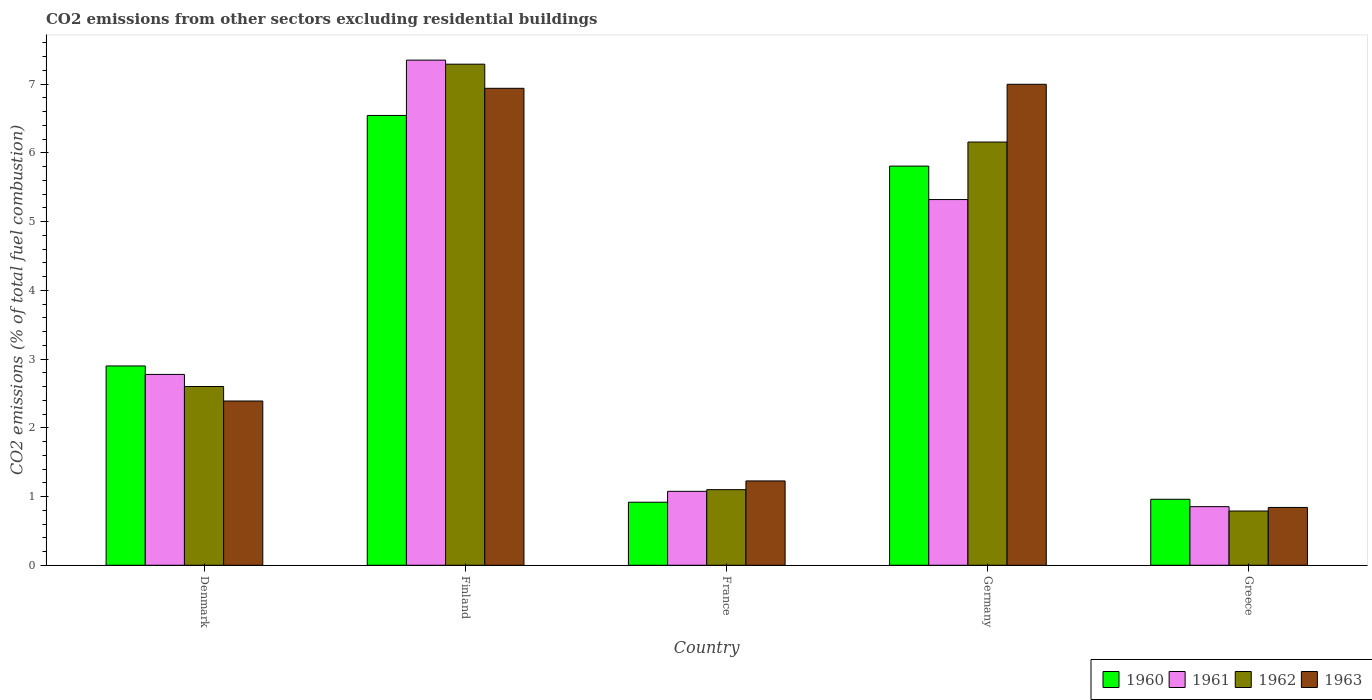How many groups of bars are there?
Your answer should be compact. 5. How many bars are there on the 2nd tick from the right?
Offer a terse response. 4. What is the label of the 4th group of bars from the left?
Your answer should be very brief. Germany. In how many cases, is the number of bars for a given country not equal to the number of legend labels?
Your answer should be very brief. 0. What is the total CO2 emitted in 1963 in Greece?
Ensure brevity in your answer.  0.84. Across all countries, what is the maximum total CO2 emitted in 1961?
Make the answer very short. 7.35. Across all countries, what is the minimum total CO2 emitted in 1961?
Offer a very short reply. 0.85. In which country was the total CO2 emitted in 1963 maximum?
Ensure brevity in your answer.  Germany. In which country was the total CO2 emitted in 1963 minimum?
Ensure brevity in your answer.  Greece. What is the total total CO2 emitted in 1963 in the graph?
Give a very brief answer. 18.4. What is the difference between the total CO2 emitted in 1962 in Finland and that in Germany?
Give a very brief answer. 1.13. What is the difference between the total CO2 emitted in 1963 in Greece and the total CO2 emitted in 1962 in Denmark?
Offer a very short reply. -1.76. What is the average total CO2 emitted in 1962 per country?
Your response must be concise. 3.59. What is the difference between the total CO2 emitted of/in 1961 and total CO2 emitted of/in 1962 in France?
Keep it short and to the point. -0.02. In how many countries, is the total CO2 emitted in 1960 greater than 5.2?
Make the answer very short. 2. What is the ratio of the total CO2 emitted in 1960 in Germany to that in Greece?
Ensure brevity in your answer.  6.05. What is the difference between the highest and the second highest total CO2 emitted in 1961?
Provide a succinct answer. -2.54. What is the difference between the highest and the lowest total CO2 emitted in 1960?
Offer a terse response. 5.63. Is the sum of the total CO2 emitted in 1963 in Finland and France greater than the maximum total CO2 emitted in 1960 across all countries?
Give a very brief answer. Yes. Is it the case that in every country, the sum of the total CO2 emitted in 1961 and total CO2 emitted in 1962 is greater than the sum of total CO2 emitted in 1963 and total CO2 emitted in 1960?
Your response must be concise. No. Is it the case that in every country, the sum of the total CO2 emitted in 1962 and total CO2 emitted in 1963 is greater than the total CO2 emitted in 1960?
Ensure brevity in your answer.  Yes. Are all the bars in the graph horizontal?
Offer a terse response. No. How many countries are there in the graph?
Offer a very short reply. 5. Are the values on the major ticks of Y-axis written in scientific E-notation?
Ensure brevity in your answer.  No. Does the graph contain any zero values?
Keep it short and to the point. No. Does the graph contain grids?
Keep it short and to the point. No. What is the title of the graph?
Your response must be concise. CO2 emissions from other sectors excluding residential buildings. What is the label or title of the X-axis?
Keep it short and to the point. Country. What is the label or title of the Y-axis?
Make the answer very short. CO2 emissions (% of total fuel combustion). What is the CO2 emissions (% of total fuel combustion) of 1960 in Denmark?
Offer a terse response. 2.9. What is the CO2 emissions (% of total fuel combustion) in 1961 in Denmark?
Offer a terse response. 2.78. What is the CO2 emissions (% of total fuel combustion) of 1962 in Denmark?
Offer a very short reply. 2.6. What is the CO2 emissions (% of total fuel combustion) of 1963 in Denmark?
Offer a terse response. 2.39. What is the CO2 emissions (% of total fuel combustion) of 1960 in Finland?
Provide a short and direct response. 6.54. What is the CO2 emissions (% of total fuel combustion) of 1961 in Finland?
Keep it short and to the point. 7.35. What is the CO2 emissions (% of total fuel combustion) of 1962 in Finland?
Make the answer very short. 7.29. What is the CO2 emissions (% of total fuel combustion) in 1963 in Finland?
Your answer should be compact. 6.94. What is the CO2 emissions (% of total fuel combustion) in 1960 in France?
Your answer should be compact. 0.92. What is the CO2 emissions (% of total fuel combustion) in 1961 in France?
Make the answer very short. 1.08. What is the CO2 emissions (% of total fuel combustion) in 1962 in France?
Your answer should be very brief. 1.1. What is the CO2 emissions (% of total fuel combustion) of 1963 in France?
Ensure brevity in your answer.  1.23. What is the CO2 emissions (% of total fuel combustion) in 1960 in Germany?
Provide a succinct answer. 5.81. What is the CO2 emissions (% of total fuel combustion) in 1961 in Germany?
Your response must be concise. 5.32. What is the CO2 emissions (% of total fuel combustion) of 1962 in Germany?
Make the answer very short. 6.16. What is the CO2 emissions (% of total fuel combustion) in 1963 in Germany?
Your answer should be very brief. 7. What is the CO2 emissions (% of total fuel combustion) of 1960 in Greece?
Offer a very short reply. 0.96. What is the CO2 emissions (% of total fuel combustion) of 1961 in Greece?
Keep it short and to the point. 0.85. What is the CO2 emissions (% of total fuel combustion) of 1962 in Greece?
Your answer should be very brief. 0.79. What is the CO2 emissions (% of total fuel combustion) in 1963 in Greece?
Ensure brevity in your answer.  0.84. Across all countries, what is the maximum CO2 emissions (% of total fuel combustion) in 1960?
Ensure brevity in your answer.  6.54. Across all countries, what is the maximum CO2 emissions (% of total fuel combustion) in 1961?
Offer a very short reply. 7.35. Across all countries, what is the maximum CO2 emissions (% of total fuel combustion) of 1962?
Your response must be concise. 7.29. Across all countries, what is the maximum CO2 emissions (% of total fuel combustion) in 1963?
Provide a succinct answer. 7. Across all countries, what is the minimum CO2 emissions (% of total fuel combustion) in 1960?
Make the answer very short. 0.92. Across all countries, what is the minimum CO2 emissions (% of total fuel combustion) of 1961?
Give a very brief answer. 0.85. Across all countries, what is the minimum CO2 emissions (% of total fuel combustion) in 1962?
Make the answer very short. 0.79. Across all countries, what is the minimum CO2 emissions (% of total fuel combustion) in 1963?
Offer a very short reply. 0.84. What is the total CO2 emissions (% of total fuel combustion) in 1960 in the graph?
Keep it short and to the point. 17.13. What is the total CO2 emissions (% of total fuel combustion) of 1961 in the graph?
Make the answer very short. 17.38. What is the total CO2 emissions (% of total fuel combustion) of 1962 in the graph?
Ensure brevity in your answer.  17.94. What is the total CO2 emissions (% of total fuel combustion) of 1963 in the graph?
Keep it short and to the point. 18.4. What is the difference between the CO2 emissions (% of total fuel combustion) of 1960 in Denmark and that in Finland?
Give a very brief answer. -3.64. What is the difference between the CO2 emissions (% of total fuel combustion) of 1961 in Denmark and that in Finland?
Your response must be concise. -4.57. What is the difference between the CO2 emissions (% of total fuel combustion) in 1962 in Denmark and that in Finland?
Your response must be concise. -4.69. What is the difference between the CO2 emissions (% of total fuel combustion) of 1963 in Denmark and that in Finland?
Offer a terse response. -4.55. What is the difference between the CO2 emissions (% of total fuel combustion) in 1960 in Denmark and that in France?
Ensure brevity in your answer.  1.98. What is the difference between the CO2 emissions (% of total fuel combustion) in 1961 in Denmark and that in France?
Offer a terse response. 1.7. What is the difference between the CO2 emissions (% of total fuel combustion) of 1962 in Denmark and that in France?
Provide a short and direct response. 1.5. What is the difference between the CO2 emissions (% of total fuel combustion) of 1963 in Denmark and that in France?
Your answer should be compact. 1.16. What is the difference between the CO2 emissions (% of total fuel combustion) in 1960 in Denmark and that in Germany?
Make the answer very short. -2.91. What is the difference between the CO2 emissions (% of total fuel combustion) in 1961 in Denmark and that in Germany?
Give a very brief answer. -2.54. What is the difference between the CO2 emissions (% of total fuel combustion) in 1962 in Denmark and that in Germany?
Offer a terse response. -3.56. What is the difference between the CO2 emissions (% of total fuel combustion) in 1963 in Denmark and that in Germany?
Ensure brevity in your answer.  -4.61. What is the difference between the CO2 emissions (% of total fuel combustion) in 1960 in Denmark and that in Greece?
Make the answer very short. 1.94. What is the difference between the CO2 emissions (% of total fuel combustion) of 1961 in Denmark and that in Greece?
Keep it short and to the point. 1.92. What is the difference between the CO2 emissions (% of total fuel combustion) in 1962 in Denmark and that in Greece?
Make the answer very short. 1.81. What is the difference between the CO2 emissions (% of total fuel combustion) of 1963 in Denmark and that in Greece?
Offer a terse response. 1.55. What is the difference between the CO2 emissions (% of total fuel combustion) in 1960 in Finland and that in France?
Your response must be concise. 5.63. What is the difference between the CO2 emissions (% of total fuel combustion) of 1961 in Finland and that in France?
Provide a short and direct response. 6.27. What is the difference between the CO2 emissions (% of total fuel combustion) of 1962 in Finland and that in France?
Offer a terse response. 6.19. What is the difference between the CO2 emissions (% of total fuel combustion) of 1963 in Finland and that in France?
Offer a very short reply. 5.71. What is the difference between the CO2 emissions (% of total fuel combustion) of 1960 in Finland and that in Germany?
Your response must be concise. 0.74. What is the difference between the CO2 emissions (% of total fuel combustion) in 1961 in Finland and that in Germany?
Keep it short and to the point. 2.03. What is the difference between the CO2 emissions (% of total fuel combustion) in 1962 in Finland and that in Germany?
Your response must be concise. 1.13. What is the difference between the CO2 emissions (% of total fuel combustion) of 1963 in Finland and that in Germany?
Keep it short and to the point. -0.06. What is the difference between the CO2 emissions (% of total fuel combustion) of 1960 in Finland and that in Greece?
Provide a succinct answer. 5.58. What is the difference between the CO2 emissions (% of total fuel combustion) in 1961 in Finland and that in Greece?
Ensure brevity in your answer.  6.5. What is the difference between the CO2 emissions (% of total fuel combustion) in 1962 in Finland and that in Greece?
Provide a short and direct response. 6.5. What is the difference between the CO2 emissions (% of total fuel combustion) of 1963 in Finland and that in Greece?
Keep it short and to the point. 6.1. What is the difference between the CO2 emissions (% of total fuel combustion) of 1960 in France and that in Germany?
Give a very brief answer. -4.89. What is the difference between the CO2 emissions (% of total fuel combustion) in 1961 in France and that in Germany?
Provide a short and direct response. -4.25. What is the difference between the CO2 emissions (% of total fuel combustion) in 1962 in France and that in Germany?
Your answer should be very brief. -5.06. What is the difference between the CO2 emissions (% of total fuel combustion) of 1963 in France and that in Germany?
Your answer should be compact. -5.77. What is the difference between the CO2 emissions (% of total fuel combustion) in 1960 in France and that in Greece?
Offer a very short reply. -0.04. What is the difference between the CO2 emissions (% of total fuel combustion) in 1961 in France and that in Greece?
Offer a terse response. 0.22. What is the difference between the CO2 emissions (% of total fuel combustion) of 1962 in France and that in Greece?
Keep it short and to the point. 0.31. What is the difference between the CO2 emissions (% of total fuel combustion) in 1963 in France and that in Greece?
Make the answer very short. 0.39. What is the difference between the CO2 emissions (% of total fuel combustion) of 1960 in Germany and that in Greece?
Your response must be concise. 4.85. What is the difference between the CO2 emissions (% of total fuel combustion) of 1961 in Germany and that in Greece?
Provide a succinct answer. 4.47. What is the difference between the CO2 emissions (% of total fuel combustion) of 1962 in Germany and that in Greece?
Ensure brevity in your answer.  5.37. What is the difference between the CO2 emissions (% of total fuel combustion) of 1963 in Germany and that in Greece?
Make the answer very short. 6.16. What is the difference between the CO2 emissions (% of total fuel combustion) of 1960 in Denmark and the CO2 emissions (% of total fuel combustion) of 1961 in Finland?
Your response must be concise. -4.45. What is the difference between the CO2 emissions (% of total fuel combustion) of 1960 in Denmark and the CO2 emissions (% of total fuel combustion) of 1962 in Finland?
Provide a short and direct response. -4.39. What is the difference between the CO2 emissions (% of total fuel combustion) of 1960 in Denmark and the CO2 emissions (% of total fuel combustion) of 1963 in Finland?
Offer a very short reply. -4.04. What is the difference between the CO2 emissions (% of total fuel combustion) of 1961 in Denmark and the CO2 emissions (% of total fuel combustion) of 1962 in Finland?
Provide a succinct answer. -4.51. What is the difference between the CO2 emissions (% of total fuel combustion) in 1961 in Denmark and the CO2 emissions (% of total fuel combustion) in 1963 in Finland?
Offer a very short reply. -4.16. What is the difference between the CO2 emissions (% of total fuel combustion) of 1962 in Denmark and the CO2 emissions (% of total fuel combustion) of 1963 in Finland?
Make the answer very short. -4.34. What is the difference between the CO2 emissions (% of total fuel combustion) of 1960 in Denmark and the CO2 emissions (% of total fuel combustion) of 1961 in France?
Your response must be concise. 1.82. What is the difference between the CO2 emissions (% of total fuel combustion) of 1960 in Denmark and the CO2 emissions (% of total fuel combustion) of 1962 in France?
Offer a very short reply. 1.8. What is the difference between the CO2 emissions (% of total fuel combustion) in 1960 in Denmark and the CO2 emissions (% of total fuel combustion) in 1963 in France?
Your response must be concise. 1.67. What is the difference between the CO2 emissions (% of total fuel combustion) of 1961 in Denmark and the CO2 emissions (% of total fuel combustion) of 1962 in France?
Provide a succinct answer. 1.68. What is the difference between the CO2 emissions (% of total fuel combustion) in 1961 in Denmark and the CO2 emissions (% of total fuel combustion) in 1963 in France?
Your response must be concise. 1.55. What is the difference between the CO2 emissions (% of total fuel combustion) in 1962 in Denmark and the CO2 emissions (% of total fuel combustion) in 1963 in France?
Your response must be concise. 1.37. What is the difference between the CO2 emissions (% of total fuel combustion) of 1960 in Denmark and the CO2 emissions (% of total fuel combustion) of 1961 in Germany?
Make the answer very short. -2.42. What is the difference between the CO2 emissions (% of total fuel combustion) of 1960 in Denmark and the CO2 emissions (% of total fuel combustion) of 1962 in Germany?
Your response must be concise. -3.26. What is the difference between the CO2 emissions (% of total fuel combustion) of 1960 in Denmark and the CO2 emissions (% of total fuel combustion) of 1963 in Germany?
Provide a succinct answer. -4.1. What is the difference between the CO2 emissions (% of total fuel combustion) in 1961 in Denmark and the CO2 emissions (% of total fuel combustion) in 1962 in Germany?
Provide a short and direct response. -3.38. What is the difference between the CO2 emissions (% of total fuel combustion) in 1961 in Denmark and the CO2 emissions (% of total fuel combustion) in 1963 in Germany?
Your answer should be very brief. -4.22. What is the difference between the CO2 emissions (% of total fuel combustion) in 1962 in Denmark and the CO2 emissions (% of total fuel combustion) in 1963 in Germany?
Make the answer very short. -4.4. What is the difference between the CO2 emissions (% of total fuel combustion) in 1960 in Denmark and the CO2 emissions (% of total fuel combustion) in 1961 in Greece?
Make the answer very short. 2.05. What is the difference between the CO2 emissions (% of total fuel combustion) of 1960 in Denmark and the CO2 emissions (% of total fuel combustion) of 1962 in Greece?
Your answer should be compact. 2.11. What is the difference between the CO2 emissions (% of total fuel combustion) of 1960 in Denmark and the CO2 emissions (% of total fuel combustion) of 1963 in Greece?
Your response must be concise. 2.06. What is the difference between the CO2 emissions (% of total fuel combustion) in 1961 in Denmark and the CO2 emissions (% of total fuel combustion) in 1962 in Greece?
Provide a short and direct response. 1.99. What is the difference between the CO2 emissions (% of total fuel combustion) of 1961 in Denmark and the CO2 emissions (% of total fuel combustion) of 1963 in Greece?
Offer a very short reply. 1.94. What is the difference between the CO2 emissions (% of total fuel combustion) in 1962 in Denmark and the CO2 emissions (% of total fuel combustion) in 1963 in Greece?
Offer a very short reply. 1.76. What is the difference between the CO2 emissions (% of total fuel combustion) of 1960 in Finland and the CO2 emissions (% of total fuel combustion) of 1961 in France?
Make the answer very short. 5.47. What is the difference between the CO2 emissions (% of total fuel combustion) of 1960 in Finland and the CO2 emissions (% of total fuel combustion) of 1962 in France?
Provide a succinct answer. 5.44. What is the difference between the CO2 emissions (% of total fuel combustion) of 1960 in Finland and the CO2 emissions (% of total fuel combustion) of 1963 in France?
Ensure brevity in your answer.  5.32. What is the difference between the CO2 emissions (% of total fuel combustion) of 1961 in Finland and the CO2 emissions (% of total fuel combustion) of 1962 in France?
Provide a succinct answer. 6.25. What is the difference between the CO2 emissions (% of total fuel combustion) in 1961 in Finland and the CO2 emissions (% of total fuel combustion) in 1963 in France?
Give a very brief answer. 6.12. What is the difference between the CO2 emissions (% of total fuel combustion) of 1962 in Finland and the CO2 emissions (% of total fuel combustion) of 1963 in France?
Your response must be concise. 6.06. What is the difference between the CO2 emissions (% of total fuel combustion) in 1960 in Finland and the CO2 emissions (% of total fuel combustion) in 1961 in Germany?
Ensure brevity in your answer.  1.22. What is the difference between the CO2 emissions (% of total fuel combustion) of 1960 in Finland and the CO2 emissions (% of total fuel combustion) of 1962 in Germany?
Provide a short and direct response. 0.39. What is the difference between the CO2 emissions (% of total fuel combustion) in 1960 in Finland and the CO2 emissions (% of total fuel combustion) in 1963 in Germany?
Provide a succinct answer. -0.45. What is the difference between the CO2 emissions (% of total fuel combustion) in 1961 in Finland and the CO2 emissions (% of total fuel combustion) in 1962 in Germany?
Offer a terse response. 1.19. What is the difference between the CO2 emissions (% of total fuel combustion) in 1961 in Finland and the CO2 emissions (% of total fuel combustion) in 1963 in Germany?
Your answer should be compact. 0.35. What is the difference between the CO2 emissions (% of total fuel combustion) in 1962 in Finland and the CO2 emissions (% of total fuel combustion) in 1963 in Germany?
Your answer should be compact. 0.29. What is the difference between the CO2 emissions (% of total fuel combustion) in 1960 in Finland and the CO2 emissions (% of total fuel combustion) in 1961 in Greece?
Provide a short and direct response. 5.69. What is the difference between the CO2 emissions (% of total fuel combustion) in 1960 in Finland and the CO2 emissions (% of total fuel combustion) in 1962 in Greece?
Offer a terse response. 5.76. What is the difference between the CO2 emissions (% of total fuel combustion) of 1960 in Finland and the CO2 emissions (% of total fuel combustion) of 1963 in Greece?
Provide a succinct answer. 5.7. What is the difference between the CO2 emissions (% of total fuel combustion) in 1961 in Finland and the CO2 emissions (% of total fuel combustion) in 1962 in Greece?
Ensure brevity in your answer.  6.56. What is the difference between the CO2 emissions (% of total fuel combustion) of 1961 in Finland and the CO2 emissions (% of total fuel combustion) of 1963 in Greece?
Keep it short and to the point. 6.51. What is the difference between the CO2 emissions (% of total fuel combustion) of 1962 in Finland and the CO2 emissions (% of total fuel combustion) of 1963 in Greece?
Your response must be concise. 6.45. What is the difference between the CO2 emissions (% of total fuel combustion) in 1960 in France and the CO2 emissions (% of total fuel combustion) in 1961 in Germany?
Give a very brief answer. -4.4. What is the difference between the CO2 emissions (% of total fuel combustion) of 1960 in France and the CO2 emissions (% of total fuel combustion) of 1962 in Germany?
Give a very brief answer. -5.24. What is the difference between the CO2 emissions (% of total fuel combustion) of 1960 in France and the CO2 emissions (% of total fuel combustion) of 1963 in Germany?
Your answer should be very brief. -6.08. What is the difference between the CO2 emissions (% of total fuel combustion) of 1961 in France and the CO2 emissions (% of total fuel combustion) of 1962 in Germany?
Ensure brevity in your answer.  -5.08. What is the difference between the CO2 emissions (% of total fuel combustion) in 1961 in France and the CO2 emissions (% of total fuel combustion) in 1963 in Germany?
Your answer should be very brief. -5.92. What is the difference between the CO2 emissions (% of total fuel combustion) in 1962 in France and the CO2 emissions (% of total fuel combustion) in 1963 in Germany?
Your answer should be very brief. -5.9. What is the difference between the CO2 emissions (% of total fuel combustion) of 1960 in France and the CO2 emissions (% of total fuel combustion) of 1961 in Greece?
Make the answer very short. 0.06. What is the difference between the CO2 emissions (% of total fuel combustion) of 1960 in France and the CO2 emissions (% of total fuel combustion) of 1962 in Greece?
Your response must be concise. 0.13. What is the difference between the CO2 emissions (% of total fuel combustion) in 1960 in France and the CO2 emissions (% of total fuel combustion) in 1963 in Greece?
Ensure brevity in your answer.  0.08. What is the difference between the CO2 emissions (% of total fuel combustion) of 1961 in France and the CO2 emissions (% of total fuel combustion) of 1962 in Greece?
Offer a very short reply. 0.29. What is the difference between the CO2 emissions (% of total fuel combustion) in 1961 in France and the CO2 emissions (% of total fuel combustion) in 1963 in Greece?
Your answer should be compact. 0.23. What is the difference between the CO2 emissions (% of total fuel combustion) of 1962 in France and the CO2 emissions (% of total fuel combustion) of 1963 in Greece?
Make the answer very short. 0.26. What is the difference between the CO2 emissions (% of total fuel combustion) of 1960 in Germany and the CO2 emissions (% of total fuel combustion) of 1961 in Greece?
Offer a very short reply. 4.96. What is the difference between the CO2 emissions (% of total fuel combustion) in 1960 in Germany and the CO2 emissions (% of total fuel combustion) in 1962 in Greece?
Your response must be concise. 5.02. What is the difference between the CO2 emissions (% of total fuel combustion) in 1960 in Germany and the CO2 emissions (% of total fuel combustion) in 1963 in Greece?
Provide a succinct answer. 4.97. What is the difference between the CO2 emissions (% of total fuel combustion) of 1961 in Germany and the CO2 emissions (% of total fuel combustion) of 1962 in Greece?
Make the answer very short. 4.53. What is the difference between the CO2 emissions (% of total fuel combustion) of 1961 in Germany and the CO2 emissions (% of total fuel combustion) of 1963 in Greece?
Provide a short and direct response. 4.48. What is the difference between the CO2 emissions (% of total fuel combustion) in 1962 in Germany and the CO2 emissions (% of total fuel combustion) in 1963 in Greece?
Offer a very short reply. 5.32. What is the average CO2 emissions (% of total fuel combustion) in 1960 per country?
Your answer should be compact. 3.43. What is the average CO2 emissions (% of total fuel combustion) in 1961 per country?
Your answer should be compact. 3.48. What is the average CO2 emissions (% of total fuel combustion) of 1962 per country?
Keep it short and to the point. 3.59. What is the average CO2 emissions (% of total fuel combustion) in 1963 per country?
Offer a terse response. 3.68. What is the difference between the CO2 emissions (% of total fuel combustion) of 1960 and CO2 emissions (% of total fuel combustion) of 1961 in Denmark?
Your response must be concise. 0.12. What is the difference between the CO2 emissions (% of total fuel combustion) in 1960 and CO2 emissions (% of total fuel combustion) in 1962 in Denmark?
Ensure brevity in your answer.  0.3. What is the difference between the CO2 emissions (% of total fuel combustion) of 1960 and CO2 emissions (% of total fuel combustion) of 1963 in Denmark?
Your answer should be very brief. 0.51. What is the difference between the CO2 emissions (% of total fuel combustion) in 1961 and CO2 emissions (% of total fuel combustion) in 1962 in Denmark?
Provide a succinct answer. 0.18. What is the difference between the CO2 emissions (% of total fuel combustion) of 1961 and CO2 emissions (% of total fuel combustion) of 1963 in Denmark?
Provide a short and direct response. 0.39. What is the difference between the CO2 emissions (% of total fuel combustion) in 1962 and CO2 emissions (% of total fuel combustion) in 1963 in Denmark?
Keep it short and to the point. 0.21. What is the difference between the CO2 emissions (% of total fuel combustion) in 1960 and CO2 emissions (% of total fuel combustion) in 1961 in Finland?
Offer a terse response. -0.81. What is the difference between the CO2 emissions (% of total fuel combustion) of 1960 and CO2 emissions (% of total fuel combustion) of 1962 in Finland?
Ensure brevity in your answer.  -0.75. What is the difference between the CO2 emissions (% of total fuel combustion) in 1960 and CO2 emissions (% of total fuel combustion) in 1963 in Finland?
Provide a short and direct response. -0.4. What is the difference between the CO2 emissions (% of total fuel combustion) in 1961 and CO2 emissions (% of total fuel combustion) in 1962 in Finland?
Offer a terse response. 0.06. What is the difference between the CO2 emissions (% of total fuel combustion) in 1961 and CO2 emissions (% of total fuel combustion) in 1963 in Finland?
Your answer should be very brief. 0.41. What is the difference between the CO2 emissions (% of total fuel combustion) of 1962 and CO2 emissions (% of total fuel combustion) of 1963 in Finland?
Your answer should be very brief. 0.35. What is the difference between the CO2 emissions (% of total fuel combustion) in 1960 and CO2 emissions (% of total fuel combustion) in 1961 in France?
Provide a succinct answer. -0.16. What is the difference between the CO2 emissions (% of total fuel combustion) of 1960 and CO2 emissions (% of total fuel combustion) of 1962 in France?
Offer a very short reply. -0.18. What is the difference between the CO2 emissions (% of total fuel combustion) of 1960 and CO2 emissions (% of total fuel combustion) of 1963 in France?
Provide a short and direct response. -0.31. What is the difference between the CO2 emissions (% of total fuel combustion) in 1961 and CO2 emissions (% of total fuel combustion) in 1962 in France?
Ensure brevity in your answer.  -0.02. What is the difference between the CO2 emissions (% of total fuel combustion) in 1961 and CO2 emissions (% of total fuel combustion) in 1963 in France?
Your answer should be compact. -0.15. What is the difference between the CO2 emissions (% of total fuel combustion) in 1962 and CO2 emissions (% of total fuel combustion) in 1963 in France?
Your answer should be very brief. -0.13. What is the difference between the CO2 emissions (% of total fuel combustion) in 1960 and CO2 emissions (% of total fuel combustion) in 1961 in Germany?
Ensure brevity in your answer.  0.49. What is the difference between the CO2 emissions (% of total fuel combustion) of 1960 and CO2 emissions (% of total fuel combustion) of 1962 in Germany?
Provide a succinct answer. -0.35. What is the difference between the CO2 emissions (% of total fuel combustion) in 1960 and CO2 emissions (% of total fuel combustion) in 1963 in Germany?
Give a very brief answer. -1.19. What is the difference between the CO2 emissions (% of total fuel combustion) in 1961 and CO2 emissions (% of total fuel combustion) in 1962 in Germany?
Offer a terse response. -0.84. What is the difference between the CO2 emissions (% of total fuel combustion) of 1961 and CO2 emissions (% of total fuel combustion) of 1963 in Germany?
Make the answer very short. -1.68. What is the difference between the CO2 emissions (% of total fuel combustion) of 1962 and CO2 emissions (% of total fuel combustion) of 1963 in Germany?
Your answer should be compact. -0.84. What is the difference between the CO2 emissions (% of total fuel combustion) in 1960 and CO2 emissions (% of total fuel combustion) in 1961 in Greece?
Provide a succinct answer. 0.11. What is the difference between the CO2 emissions (% of total fuel combustion) of 1960 and CO2 emissions (% of total fuel combustion) of 1962 in Greece?
Make the answer very short. 0.17. What is the difference between the CO2 emissions (% of total fuel combustion) in 1960 and CO2 emissions (% of total fuel combustion) in 1963 in Greece?
Keep it short and to the point. 0.12. What is the difference between the CO2 emissions (% of total fuel combustion) in 1961 and CO2 emissions (% of total fuel combustion) in 1962 in Greece?
Offer a terse response. 0.06. What is the difference between the CO2 emissions (% of total fuel combustion) of 1961 and CO2 emissions (% of total fuel combustion) of 1963 in Greece?
Provide a succinct answer. 0.01. What is the difference between the CO2 emissions (% of total fuel combustion) of 1962 and CO2 emissions (% of total fuel combustion) of 1963 in Greece?
Your response must be concise. -0.05. What is the ratio of the CO2 emissions (% of total fuel combustion) of 1960 in Denmark to that in Finland?
Your answer should be compact. 0.44. What is the ratio of the CO2 emissions (% of total fuel combustion) in 1961 in Denmark to that in Finland?
Your answer should be very brief. 0.38. What is the ratio of the CO2 emissions (% of total fuel combustion) in 1962 in Denmark to that in Finland?
Give a very brief answer. 0.36. What is the ratio of the CO2 emissions (% of total fuel combustion) of 1963 in Denmark to that in Finland?
Your response must be concise. 0.34. What is the ratio of the CO2 emissions (% of total fuel combustion) of 1960 in Denmark to that in France?
Keep it short and to the point. 3.16. What is the ratio of the CO2 emissions (% of total fuel combustion) in 1961 in Denmark to that in France?
Make the answer very short. 2.58. What is the ratio of the CO2 emissions (% of total fuel combustion) in 1962 in Denmark to that in France?
Your answer should be compact. 2.36. What is the ratio of the CO2 emissions (% of total fuel combustion) of 1963 in Denmark to that in France?
Give a very brief answer. 1.95. What is the ratio of the CO2 emissions (% of total fuel combustion) in 1960 in Denmark to that in Germany?
Your answer should be very brief. 0.5. What is the ratio of the CO2 emissions (% of total fuel combustion) in 1961 in Denmark to that in Germany?
Your response must be concise. 0.52. What is the ratio of the CO2 emissions (% of total fuel combustion) of 1962 in Denmark to that in Germany?
Ensure brevity in your answer.  0.42. What is the ratio of the CO2 emissions (% of total fuel combustion) in 1963 in Denmark to that in Germany?
Your answer should be compact. 0.34. What is the ratio of the CO2 emissions (% of total fuel combustion) of 1960 in Denmark to that in Greece?
Offer a very short reply. 3.02. What is the ratio of the CO2 emissions (% of total fuel combustion) of 1961 in Denmark to that in Greece?
Ensure brevity in your answer.  3.26. What is the ratio of the CO2 emissions (% of total fuel combustion) of 1962 in Denmark to that in Greece?
Offer a terse response. 3.3. What is the ratio of the CO2 emissions (% of total fuel combustion) in 1963 in Denmark to that in Greece?
Provide a short and direct response. 2.84. What is the ratio of the CO2 emissions (% of total fuel combustion) in 1960 in Finland to that in France?
Make the answer very short. 7.14. What is the ratio of the CO2 emissions (% of total fuel combustion) in 1961 in Finland to that in France?
Your answer should be compact. 6.83. What is the ratio of the CO2 emissions (% of total fuel combustion) in 1962 in Finland to that in France?
Provide a succinct answer. 6.63. What is the ratio of the CO2 emissions (% of total fuel combustion) in 1963 in Finland to that in France?
Your response must be concise. 5.66. What is the ratio of the CO2 emissions (% of total fuel combustion) of 1960 in Finland to that in Germany?
Your answer should be very brief. 1.13. What is the ratio of the CO2 emissions (% of total fuel combustion) of 1961 in Finland to that in Germany?
Give a very brief answer. 1.38. What is the ratio of the CO2 emissions (% of total fuel combustion) of 1962 in Finland to that in Germany?
Give a very brief answer. 1.18. What is the ratio of the CO2 emissions (% of total fuel combustion) of 1963 in Finland to that in Germany?
Your answer should be very brief. 0.99. What is the ratio of the CO2 emissions (% of total fuel combustion) in 1960 in Finland to that in Greece?
Provide a short and direct response. 6.82. What is the ratio of the CO2 emissions (% of total fuel combustion) of 1961 in Finland to that in Greece?
Your answer should be compact. 8.62. What is the ratio of the CO2 emissions (% of total fuel combustion) in 1962 in Finland to that in Greece?
Offer a very short reply. 9.24. What is the ratio of the CO2 emissions (% of total fuel combustion) of 1963 in Finland to that in Greece?
Provide a succinct answer. 8.25. What is the ratio of the CO2 emissions (% of total fuel combustion) in 1960 in France to that in Germany?
Your answer should be compact. 0.16. What is the ratio of the CO2 emissions (% of total fuel combustion) of 1961 in France to that in Germany?
Your answer should be compact. 0.2. What is the ratio of the CO2 emissions (% of total fuel combustion) in 1962 in France to that in Germany?
Make the answer very short. 0.18. What is the ratio of the CO2 emissions (% of total fuel combustion) of 1963 in France to that in Germany?
Your answer should be compact. 0.18. What is the ratio of the CO2 emissions (% of total fuel combustion) in 1960 in France to that in Greece?
Keep it short and to the point. 0.96. What is the ratio of the CO2 emissions (% of total fuel combustion) of 1961 in France to that in Greece?
Offer a terse response. 1.26. What is the ratio of the CO2 emissions (% of total fuel combustion) of 1962 in France to that in Greece?
Provide a succinct answer. 1.39. What is the ratio of the CO2 emissions (% of total fuel combustion) of 1963 in France to that in Greece?
Your response must be concise. 1.46. What is the ratio of the CO2 emissions (% of total fuel combustion) in 1960 in Germany to that in Greece?
Keep it short and to the point. 6.05. What is the ratio of the CO2 emissions (% of total fuel combustion) of 1961 in Germany to that in Greece?
Provide a short and direct response. 6.24. What is the ratio of the CO2 emissions (% of total fuel combustion) in 1962 in Germany to that in Greece?
Make the answer very short. 7.8. What is the ratio of the CO2 emissions (% of total fuel combustion) of 1963 in Germany to that in Greece?
Provide a succinct answer. 8.32. What is the difference between the highest and the second highest CO2 emissions (% of total fuel combustion) of 1960?
Provide a succinct answer. 0.74. What is the difference between the highest and the second highest CO2 emissions (% of total fuel combustion) of 1961?
Your answer should be very brief. 2.03. What is the difference between the highest and the second highest CO2 emissions (% of total fuel combustion) in 1962?
Your answer should be very brief. 1.13. What is the difference between the highest and the second highest CO2 emissions (% of total fuel combustion) of 1963?
Give a very brief answer. 0.06. What is the difference between the highest and the lowest CO2 emissions (% of total fuel combustion) in 1960?
Offer a very short reply. 5.63. What is the difference between the highest and the lowest CO2 emissions (% of total fuel combustion) in 1961?
Give a very brief answer. 6.5. What is the difference between the highest and the lowest CO2 emissions (% of total fuel combustion) in 1962?
Make the answer very short. 6.5. What is the difference between the highest and the lowest CO2 emissions (% of total fuel combustion) in 1963?
Your response must be concise. 6.16. 